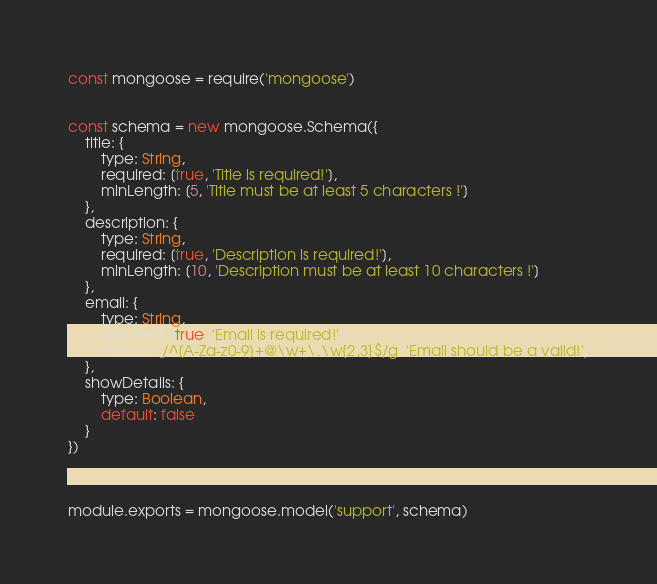<code> <loc_0><loc_0><loc_500><loc_500><_JavaScript_>const mongoose = require('mongoose')


const schema = new mongoose.Schema({
    title: {
        type: String,
        required: [true, 'Title is required!'],
        minLength: [5, 'Title must be at least 5 characters !']
    },
    description: {
        type: String,
        required: [true, 'Description is required!'],
        minLength: [10, 'Description must be at least 10 characters !']
    },
    email: {
        type: String,
        required: [true, 'Email is required!'],
        match: [/^[A-Za-z0-9]+@\w+\.\w{2,3}$/g, 'Email should be a valid!']
    },
    showDetails: {
        type: Boolean,
        default: false
    }
})



module.exports = mongoose.model('support', schema)</code> 